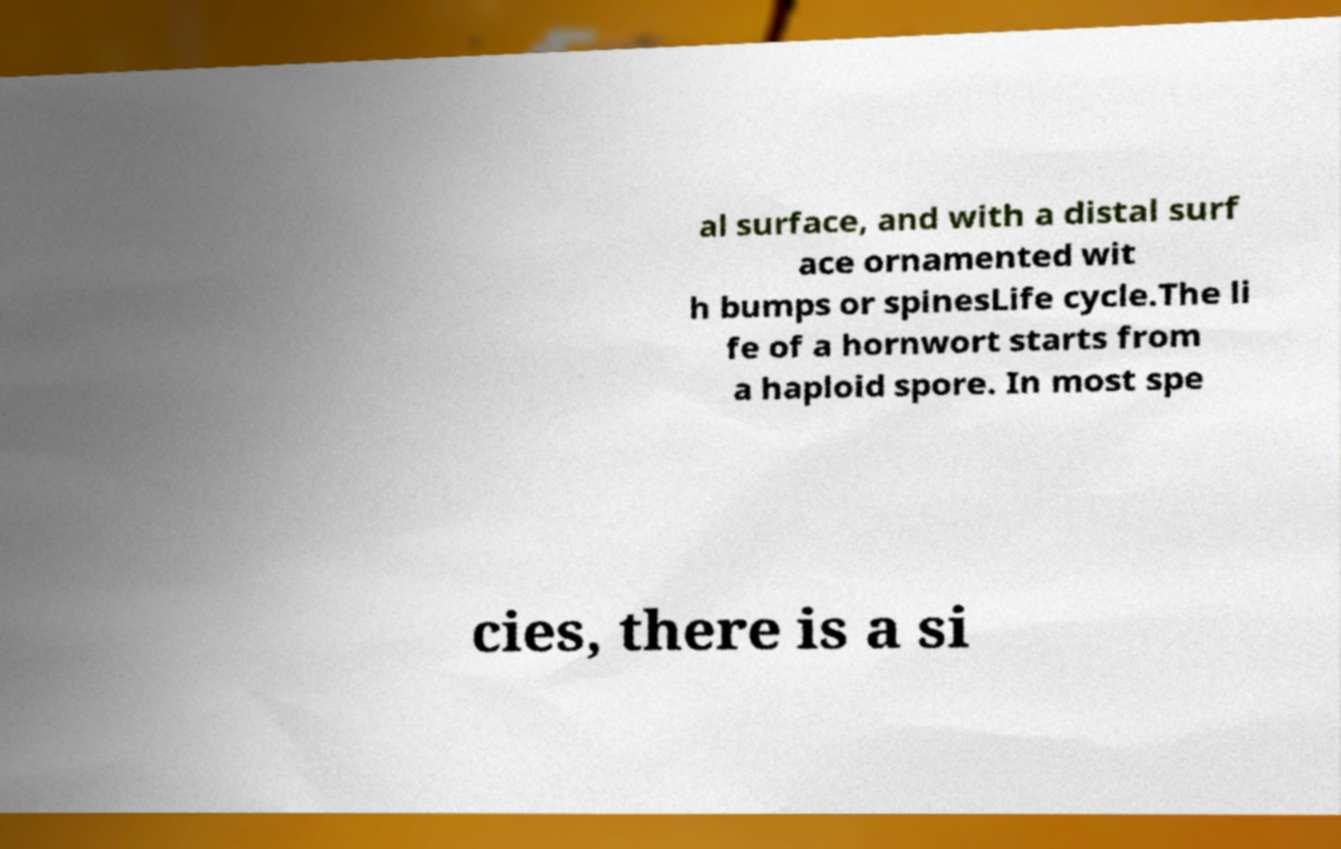I need the written content from this picture converted into text. Can you do that? al surface, and with a distal surf ace ornamented wit h bumps or spinesLife cycle.The li fe of a hornwort starts from a haploid spore. In most spe cies, there is a si 